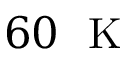Convert formula to latex. <formula><loc_0><loc_0><loc_500><loc_500>6 0 K</formula> 